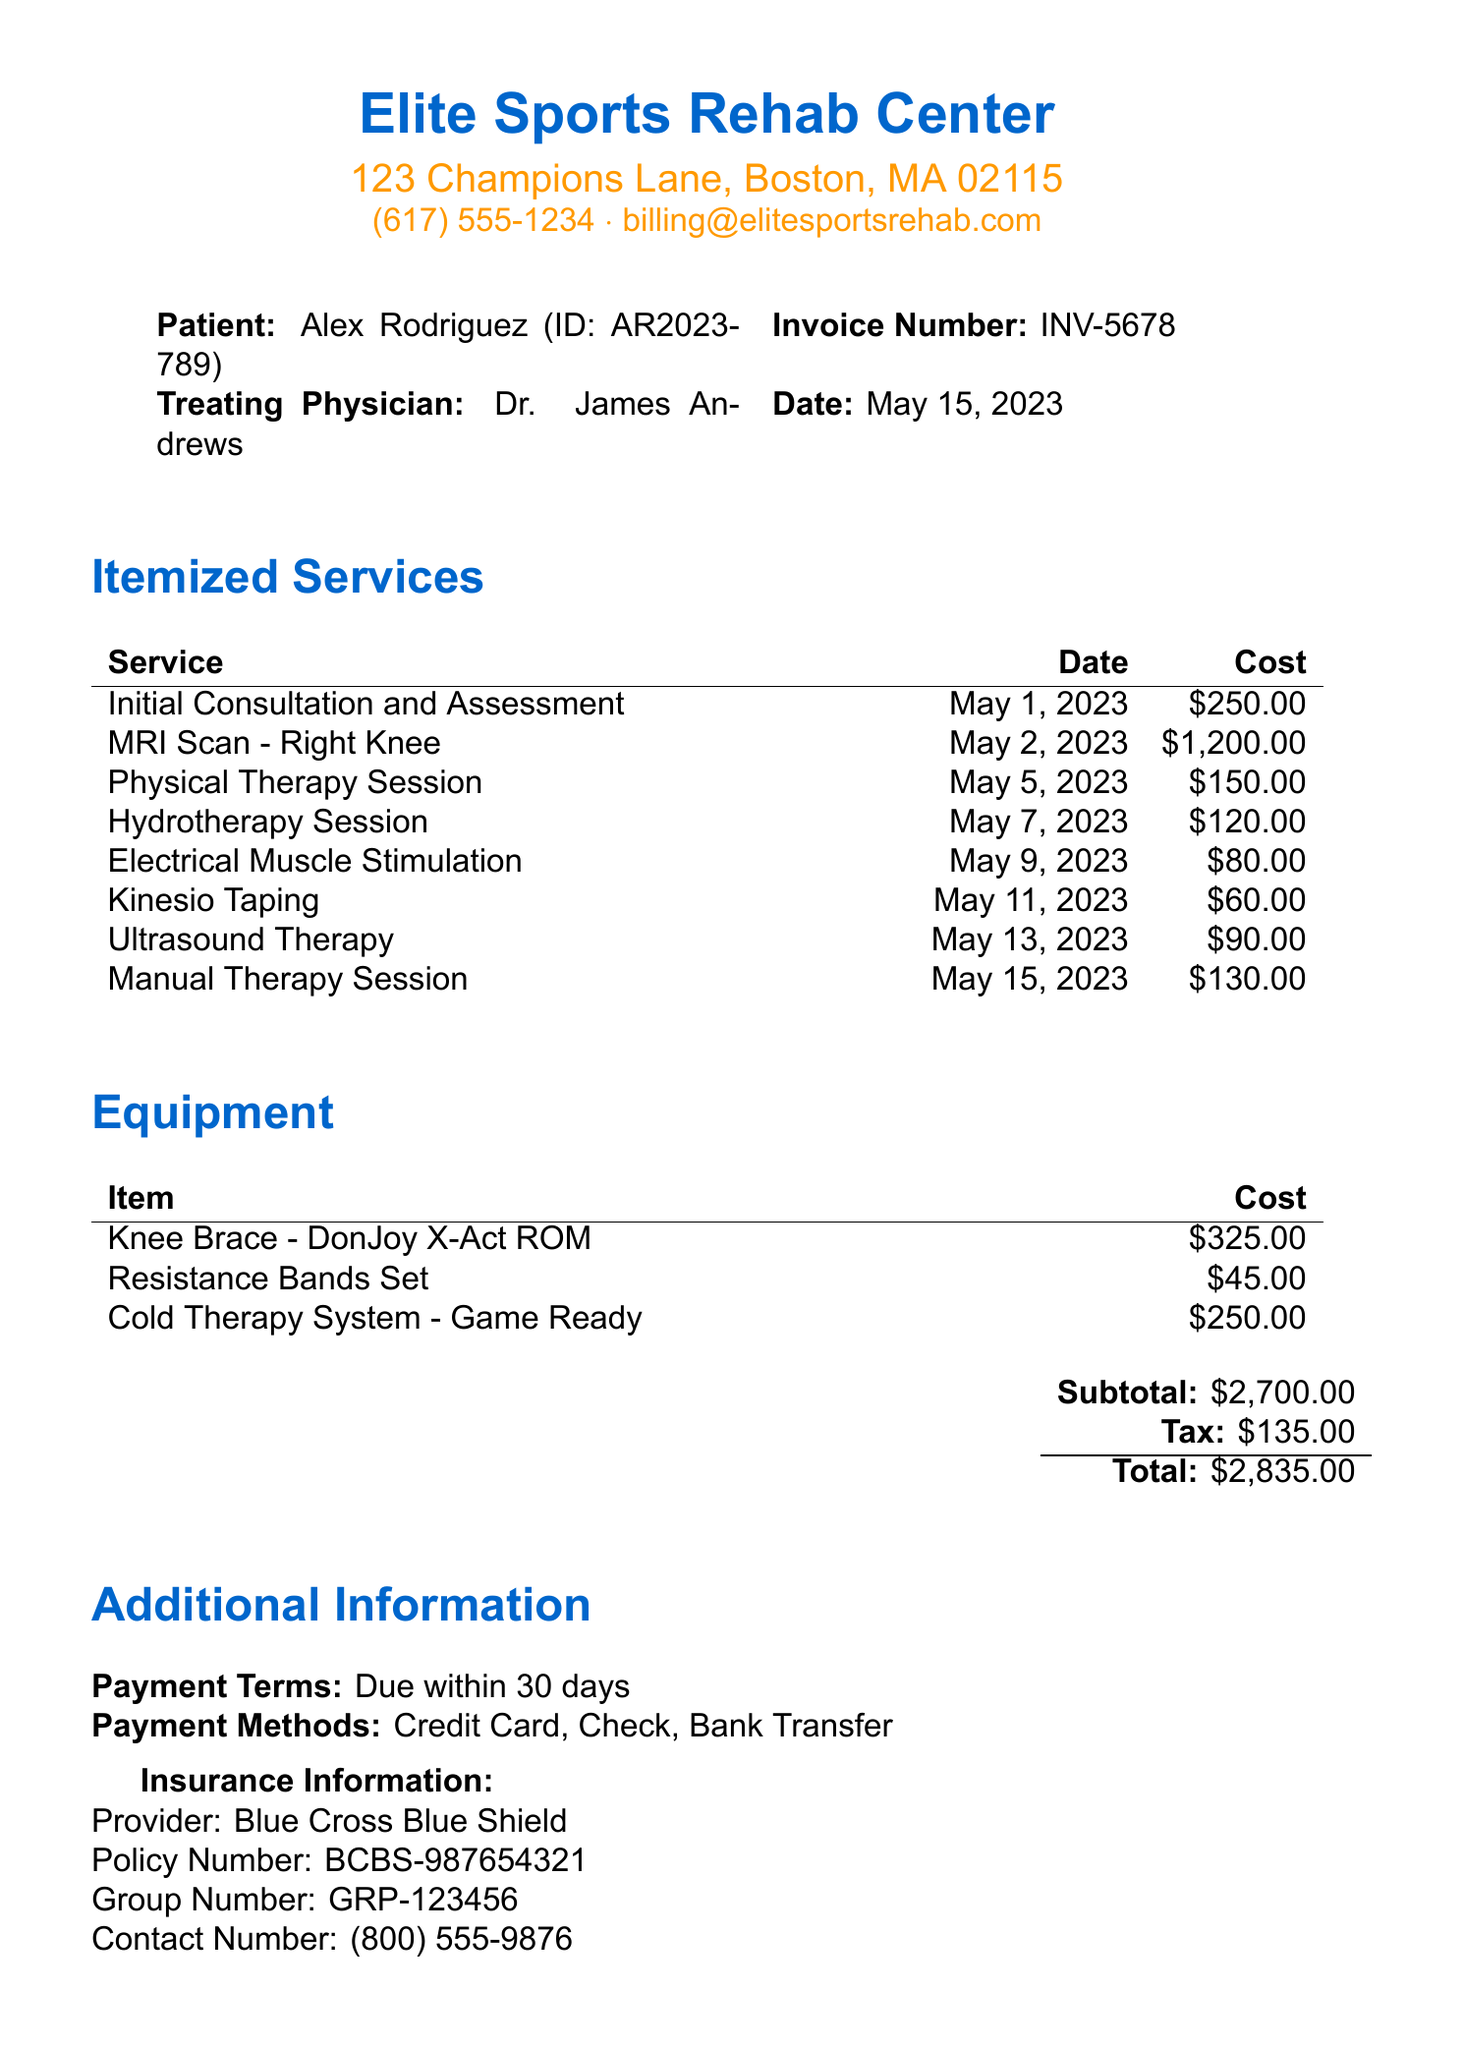what is the patient's name? The patient's name is listed at the top of the document under patient details.
Answer: Alex Rodriguez what is the invoice number? The invoice number is specified in the document near the patient information section.
Answer: INV-5678 what is the total amount due? The total amount due is indicated in the financial summary at the end of the document.
Answer: $2,835.00 who is the treating physician? The treating physician's name is mentioned in the patient details section of the invoice.
Answer: Dr. James Andrews when was the Initial Consultation and Assessment? The date for the Initial Consultation and Assessment is provided in the itemized services section.
Answer: May 1, 2023 how much did the MRI Scan - Right Knee cost? The cost for the MRI scan is part of the itemized services listed in the document.
Answer: $1,200.00 which insurance provider is listed? The insurance information section specifies the provider for the patient.
Answer: Blue Cross Blue Shield how many therapy sessions are listed? The total number of therapy sessions can be determined by counting the entries in the itemized services section.
Answer: 6 sessions what payment methods are accepted? The payment methods are mentioned in the additional information section of the invoice.
Answer: Credit Card, Check, Bank Transfer what is the contact number for insurance inquiries? The contact number for the insurance provider is detailed in the insurance information section.
Answer: (800) 555-9876 